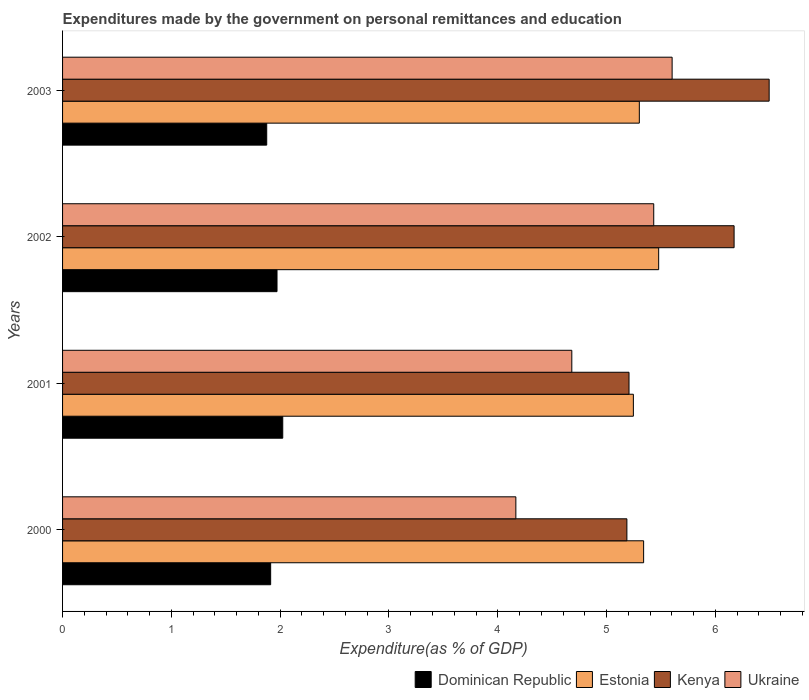How many groups of bars are there?
Provide a short and direct response. 4. Are the number of bars per tick equal to the number of legend labels?
Your answer should be very brief. Yes. What is the label of the 1st group of bars from the top?
Your response must be concise. 2003. What is the expenditures made by the government on personal remittances and education in Dominican Republic in 2001?
Offer a terse response. 2.02. Across all years, what is the maximum expenditures made by the government on personal remittances and education in Ukraine?
Keep it short and to the point. 5.6. Across all years, what is the minimum expenditures made by the government on personal remittances and education in Estonia?
Your answer should be very brief. 5.25. In which year was the expenditures made by the government on personal remittances and education in Dominican Republic maximum?
Give a very brief answer. 2001. What is the total expenditures made by the government on personal remittances and education in Kenya in the graph?
Provide a succinct answer. 23.06. What is the difference between the expenditures made by the government on personal remittances and education in Ukraine in 2001 and that in 2003?
Offer a very short reply. -0.92. What is the difference between the expenditures made by the government on personal remittances and education in Kenya in 2000 and the expenditures made by the government on personal remittances and education in Dominican Republic in 2002?
Your answer should be very brief. 3.22. What is the average expenditures made by the government on personal remittances and education in Kenya per year?
Offer a very short reply. 5.76. In the year 2002, what is the difference between the expenditures made by the government on personal remittances and education in Dominican Republic and expenditures made by the government on personal remittances and education in Estonia?
Your answer should be compact. -3.51. In how many years, is the expenditures made by the government on personal remittances and education in Dominican Republic greater than 0.4 %?
Your answer should be compact. 4. What is the ratio of the expenditures made by the government on personal remittances and education in Dominican Republic in 2000 to that in 2001?
Ensure brevity in your answer.  0.95. Is the expenditures made by the government on personal remittances and education in Kenya in 2002 less than that in 2003?
Provide a succinct answer. Yes. Is the difference between the expenditures made by the government on personal remittances and education in Dominican Republic in 2001 and 2002 greater than the difference between the expenditures made by the government on personal remittances and education in Estonia in 2001 and 2002?
Your response must be concise. Yes. What is the difference between the highest and the second highest expenditures made by the government on personal remittances and education in Ukraine?
Your response must be concise. 0.17. What is the difference between the highest and the lowest expenditures made by the government on personal remittances and education in Estonia?
Make the answer very short. 0.23. In how many years, is the expenditures made by the government on personal remittances and education in Dominican Republic greater than the average expenditures made by the government on personal remittances and education in Dominican Republic taken over all years?
Ensure brevity in your answer.  2. Is it the case that in every year, the sum of the expenditures made by the government on personal remittances and education in Ukraine and expenditures made by the government on personal remittances and education in Kenya is greater than the sum of expenditures made by the government on personal remittances and education in Dominican Republic and expenditures made by the government on personal remittances and education in Estonia?
Offer a very short reply. No. What does the 3rd bar from the top in 2001 represents?
Offer a terse response. Estonia. What does the 1st bar from the bottom in 2001 represents?
Provide a short and direct response. Dominican Republic. Is it the case that in every year, the sum of the expenditures made by the government on personal remittances and education in Estonia and expenditures made by the government on personal remittances and education in Ukraine is greater than the expenditures made by the government on personal remittances and education in Kenya?
Ensure brevity in your answer.  Yes. Are all the bars in the graph horizontal?
Keep it short and to the point. Yes. What is the difference between two consecutive major ticks on the X-axis?
Make the answer very short. 1. Does the graph contain any zero values?
Keep it short and to the point. No. Where does the legend appear in the graph?
Provide a short and direct response. Bottom right. How many legend labels are there?
Offer a terse response. 4. How are the legend labels stacked?
Your response must be concise. Horizontal. What is the title of the graph?
Provide a succinct answer. Expenditures made by the government on personal remittances and education. Does "Central African Republic" appear as one of the legend labels in the graph?
Your answer should be compact. No. What is the label or title of the X-axis?
Provide a short and direct response. Expenditure(as % of GDP). What is the Expenditure(as % of GDP) in Dominican Republic in 2000?
Ensure brevity in your answer.  1.91. What is the Expenditure(as % of GDP) of Estonia in 2000?
Provide a succinct answer. 5.34. What is the Expenditure(as % of GDP) of Kenya in 2000?
Provide a short and direct response. 5.19. What is the Expenditure(as % of GDP) of Ukraine in 2000?
Give a very brief answer. 4.17. What is the Expenditure(as % of GDP) of Dominican Republic in 2001?
Make the answer very short. 2.02. What is the Expenditure(as % of GDP) of Estonia in 2001?
Ensure brevity in your answer.  5.25. What is the Expenditure(as % of GDP) of Kenya in 2001?
Your answer should be very brief. 5.21. What is the Expenditure(as % of GDP) of Ukraine in 2001?
Your answer should be very brief. 4.68. What is the Expenditure(as % of GDP) in Dominican Republic in 2002?
Provide a short and direct response. 1.97. What is the Expenditure(as % of GDP) in Estonia in 2002?
Your answer should be compact. 5.48. What is the Expenditure(as % of GDP) in Kenya in 2002?
Provide a short and direct response. 6.17. What is the Expenditure(as % of GDP) of Ukraine in 2002?
Your answer should be very brief. 5.43. What is the Expenditure(as % of GDP) in Dominican Republic in 2003?
Provide a short and direct response. 1.88. What is the Expenditure(as % of GDP) in Estonia in 2003?
Your answer should be very brief. 5.3. What is the Expenditure(as % of GDP) of Kenya in 2003?
Give a very brief answer. 6.49. What is the Expenditure(as % of GDP) of Ukraine in 2003?
Provide a short and direct response. 5.6. Across all years, what is the maximum Expenditure(as % of GDP) of Dominican Republic?
Ensure brevity in your answer.  2.02. Across all years, what is the maximum Expenditure(as % of GDP) in Estonia?
Provide a short and direct response. 5.48. Across all years, what is the maximum Expenditure(as % of GDP) of Kenya?
Offer a very short reply. 6.49. Across all years, what is the maximum Expenditure(as % of GDP) in Ukraine?
Ensure brevity in your answer.  5.6. Across all years, what is the minimum Expenditure(as % of GDP) in Dominican Republic?
Provide a short and direct response. 1.88. Across all years, what is the minimum Expenditure(as % of GDP) of Estonia?
Make the answer very short. 5.25. Across all years, what is the minimum Expenditure(as % of GDP) of Kenya?
Your response must be concise. 5.19. Across all years, what is the minimum Expenditure(as % of GDP) in Ukraine?
Your answer should be very brief. 4.17. What is the total Expenditure(as % of GDP) in Dominican Republic in the graph?
Your answer should be compact. 7.78. What is the total Expenditure(as % of GDP) of Estonia in the graph?
Provide a short and direct response. 21.37. What is the total Expenditure(as % of GDP) in Kenya in the graph?
Your response must be concise. 23.06. What is the total Expenditure(as % of GDP) of Ukraine in the graph?
Your answer should be compact. 19.88. What is the difference between the Expenditure(as % of GDP) of Dominican Republic in 2000 and that in 2001?
Offer a terse response. -0.11. What is the difference between the Expenditure(as % of GDP) in Estonia in 2000 and that in 2001?
Your response must be concise. 0.09. What is the difference between the Expenditure(as % of GDP) of Kenya in 2000 and that in 2001?
Provide a short and direct response. -0.02. What is the difference between the Expenditure(as % of GDP) of Ukraine in 2000 and that in 2001?
Offer a terse response. -0.51. What is the difference between the Expenditure(as % of GDP) in Dominican Republic in 2000 and that in 2002?
Provide a succinct answer. -0.06. What is the difference between the Expenditure(as % of GDP) in Estonia in 2000 and that in 2002?
Your response must be concise. -0.14. What is the difference between the Expenditure(as % of GDP) of Kenya in 2000 and that in 2002?
Provide a succinct answer. -0.99. What is the difference between the Expenditure(as % of GDP) in Ukraine in 2000 and that in 2002?
Make the answer very short. -1.27. What is the difference between the Expenditure(as % of GDP) of Dominican Republic in 2000 and that in 2003?
Offer a very short reply. 0.04. What is the difference between the Expenditure(as % of GDP) in Estonia in 2000 and that in 2003?
Keep it short and to the point. 0.04. What is the difference between the Expenditure(as % of GDP) of Kenya in 2000 and that in 2003?
Your response must be concise. -1.31. What is the difference between the Expenditure(as % of GDP) of Ukraine in 2000 and that in 2003?
Offer a terse response. -1.44. What is the difference between the Expenditure(as % of GDP) of Dominican Republic in 2001 and that in 2002?
Keep it short and to the point. 0.05. What is the difference between the Expenditure(as % of GDP) in Estonia in 2001 and that in 2002?
Provide a succinct answer. -0.23. What is the difference between the Expenditure(as % of GDP) of Kenya in 2001 and that in 2002?
Keep it short and to the point. -0.97. What is the difference between the Expenditure(as % of GDP) in Ukraine in 2001 and that in 2002?
Provide a succinct answer. -0.75. What is the difference between the Expenditure(as % of GDP) of Dominican Republic in 2001 and that in 2003?
Provide a succinct answer. 0.15. What is the difference between the Expenditure(as % of GDP) in Estonia in 2001 and that in 2003?
Keep it short and to the point. -0.05. What is the difference between the Expenditure(as % of GDP) in Kenya in 2001 and that in 2003?
Make the answer very short. -1.29. What is the difference between the Expenditure(as % of GDP) in Ukraine in 2001 and that in 2003?
Your answer should be very brief. -0.92. What is the difference between the Expenditure(as % of GDP) in Dominican Republic in 2002 and that in 2003?
Provide a succinct answer. 0.09. What is the difference between the Expenditure(as % of GDP) of Estonia in 2002 and that in 2003?
Make the answer very short. 0.18. What is the difference between the Expenditure(as % of GDP) of Kenya in 2002 and that in 2003?
Provide a succinct answer. -0.32. What is the difference between the Expenditure(as % of GDP) of Ukraine in 2002 and that in 2003?
Keep it short and to the point. -0.17. What is the difference between the Expenditure(as % of GDP) of Dominican Republic in 2000 and the Expenditure(as % of GDP) of Estonia in 2001?
Make the answer very short. -3.33. What is the difference between the Expenditure(as % of GDP) in Dominican Republic in 2000 and the Expenditure(as % of GDP) in Kenya in 2001?
Give a very brief answer. -3.29. What is the difference between the Expenditure(as % of GDP) in Dominican Republic in 2000 and the Expenditure(as % of GDP) in Ukraine in 2001?
Provide a succinct answer. -2.77. What is the difference between the Expenditure(as % of GDP) in Estonia in 2000 and the Expenditure(as % of GDP) in Kenya in 2001?
Offer a very short reply. 0.13. What is the difference between the Expenditure(as % of GDP) of Estonia in 2000 and the Expenditure(as % of GDP) of Ukraine in 2001?
Ensure brevity in your answer.  0.66. What is the difference between the Expenditure(as % of GDP) of Kenya in 2000 and the Expenditure(as % of GDP) of Ukraine in 2001?
Provide a succinct answer. 0.51. What is the difference between the Expenditure(as % of GDP) of Dominican Republic in 2000 and the Expenditure(as % of GDP) of Estonia in 2002?
Give a very brief answer. -3.57. What is the difference between the Expenditure(as % of GDP) of Dominican Republic in 2000 and the Expenditure(as % of GDP) of Kenya in 2002?
Make the answer very short. -4.26. What is the difference between the Expenditure(as % of GDP) in Dominican Republic in 2000 and the Expenditure(as % of GDP) in Ukraine in 2002?
Provide a succinct answer. -3.52. What is the difference between the Expenditure(as % of GDP) in Estonia in 2000 and the Expenditure(as % of GDP) in Kenya in 2002?
Keep it short and to the point. -0.83. What is the difference between the Expenditure(as % of GDP) of Estonia in 2000 and the Expenditure(as % of GDP) of Ukraine in 2002?
Ensure brevity in your answer.  -0.09. What is the difference between the Expenditure(as % of GDP) of Kenya in 2000 and the Expenditure(as % of GDP) of Ukraine in 2002?
Ensure brevity in your answer.  -0.25. What is the difference between the Expenditure(as % of GDP) of Dominican Republic in 2000 and the Expenditure(as % of GDP) of Estonia in 2003?
Keep it short and to the point. -3.39. What is the difference between the Expenditure(as % of GDP) of Dominican Republic in 2000 and the Expenditure(as % of GDP) of Kenya in 2003?
Give a very brief answer. -4.58. What is the difference between the Expenditure(as % of GDP) in Dominican Republic in 2000 and the Expenditure(as % of GDP) in Ukraine in 2003?
Keep it short and to the point. -3.69. What is the difference between the Expenditure(as % of GDP) of Estonia in 2000 and the Expenditure(as % of GDP) of Kenya in 2003?
Keep it short and to the point. -1.15. What is the difference between the Expenditure(as % of GDP) of Estonia in 2000 and the Expenditure(as % of GDP) of Ukraine in 2003?
Make the answer very short. -0.26. What is the difference between the Expenditure(as % of GDP) in Kenya in 2000 and the Expenditure(as % of GDP) in Ukraine in 2003?
Offer a terse response. -0.42. What is the difference between the Expenditure(as % of GDP) of Dominican Republic in 2001 and the Expenditure(as % of GDP) of Estonia in 2002?
Give a very brief answer. -3.46. What is the difference between the Expenditure(as % of GDP) in Dominican Republic in 2001 and the Expenditure(as % of GDP) in Kenya in 2002?
Give a very brief answer. -4.15. What is the difference between the Expenditure(as % of GDP) of Dominican Republic in 2001 and the Expenditure(as % of GDP) of Ukraine in 2002?
Keep it short and to the point. -3.41. What is the difference between the Expenditure(as % of GDP) of Estonia in 2001 and the Expenditure(as % of GDP) of Kenya in 2002?
Offer a very short reply. -0.93. What is the difference between the Expenditure(as % of GDP) in Estonia in 2001 and the Expenditure(as % of GDP) in Ukraine in 2002?
Make the answer very short. -0.19. What is the difference between the Expenditure(as % of GDP) of Kenya in 2001 and the Expenditure(as % of GDP) of Ukraine in 2002?
Your answer should be very brief. -0.23. What is the difference between the Expenditure(as % of GDP) of Dominican Republic in 2001 and the Expenditure(as % of GDP) of Estonia in 2003?
Your answer should be very brief. -3.28. What is the difference between the Expenditure(as % of GDP) in Dominican Republic in 2001 and the Expenditure(as % of GDP) in Kenya in 2003?
Provide a succinct answer. -4.47. What is the difference between the Expenditure(as % of GDP) in Dominican Republic in 2001 and the Expenditure(as % of GDP) in Ukraine in 2003?
Your answer should be very brief. -3.58. What is the difference between the Expenditure(as % of GDP) of Estonia in 2001 and the Expenditure(as % of GDP) of Kenya in 2003?
Give a very brief answer. -1.25. What is the difference between the Expenditure(as % of GDP) in Estonia in 2001 and the Expenditure(as % of GDP) in Ukraine in 2003?
Offer a terse response. -0.36. What is the difference between the Expenditure(as % of GDP) in Kenya in 2001 and the Expenditure(as % of GDP) in Ukraine in 2003?
Give a very brief answer. -0.4. What is the difference between the Expenditure(as % of GDP) in Dominican Republic in 2002 and the Expenditure(as % of GDP) in Estonia in 2003?
Offer a terse response. -3.33. What is the difference between the Expenditure(as % of GDP) in Dominican Republic in 2002 and the Expenditure(as % of GDP) in Kenya in 2003?
Offer a terse response. -4.52. What is the difference between the Expenditure(as % of GDP) of Dominican Republic in 2002 and the Expenditure(as % of GDP) of Ukraine in 2003?
Provide a succinct answer. -3.63. What is the difference between the Expenditure(as % of GDP) in Estonia in 2002 and the Expenditure(as % of GDP) in Kenya in 2003?
Your answer should be compact. -1.02. What is the difference between the Expenditure(as % of GDP) of Estonia in 2002 and the Expenditure(as % of GDP) of Ukraine in 2003?
Offer a terse response. -0.12. What is the difference between the Expenditure(as % of GDP) of Kenya in 2002 and the Expenditure(as % of GDP) of Ukraine in 2003?
Your answer should be compact. 0.57. What is the average Expenditure(as % of GDP) in Dominican Republic per year?
Provide a succinct answer. 1.95. What is the average Expenditure(as % of GDP) of Estonia per year?
Provide a short and direct response. 5.34. What is the average Expenditure(as % of GDP) in Kenya per year?
Keep it short and to the point. 5.76. What is the average Expenditure(as % of GDP) of Ukraine per year?
Your answer should be compact. 4.97. In the year 2000, what is the difference between the Expenditure(as % of GDP) in Dominican Republic and Expenditure(as % of GDP) in Estonia?
Your answer should be compact. -3.43. In the year 2000, what is the difference between the Expenditure(as % of GDP) in Dominican Republic and Expenditure(as % of GDP) in Kenya?
Your answer should be compact. -3.27. In the year 2000, what is the difference between the Expenditure(as % of GDP) of Dominican Republic and Expenditure(as % of GDP) of Ukraine?
Provide a succinct answer. -2.25. In the year 2000, what is the difference between the Expenditure(as % of GDP) of Estonia and Expenditure(as % of GDP) of Kenya?
Ensure brevity in your answer.  0.15. In the year 2000, what is the difference between the Expenditure(as % of GDP) of Estonia and Expenditure(as % of GDP) of Ukraine?
Provide a short and direct response. 1.17. In the year 2000, what is the difference between the Expenditure(as % of GDP) of Kenya and Expenditure(as % of GDP) of Ukraine?
Offer a very short reply. 1.02. In the year 2001, what is the difference between the Expenditure(as % of GDP) of Dominican Republic and Expenditure(as % of GDP) of Estonia?
Keep it short and to the point. -3.22. In the year 2001, what is the difference between the Expenditure(as % of GDP) of Dominican Republic and Expenditure(as % of GDP) of Kenya?
Ensure brevity in your answer.  -3.18. In the year 2001, what is the difference between the Expenditure(as % of GDP) in Dominican Republic and Expenditure(as % of GDP) in Ukraine?
Provide a succinct answer. -2.66. In the year 2001, what is the difference between the Expenditure(as % of GDP) of Estonia and Expenditure(as % of GDP) of Ukraine?
Offer a very short reply. 0.57. In the year 2001, what is the difference between the Expenditure(as % of GDP) of Kenya and Expenditure(as % of GDP) of Ukraine?
Give a very brief answer. 0.53. In the year 2002, what is the difference between the Expenditure(as % of GDP) in Dominican Republic and Expenditure(as % of GDP) in Estonia?
Make the answer very short. -3.51. In the year 2002, what is the difference between the Expenditure(as % of GDP) of Dominican Republic and Expenditure(as % of GDP) of Kenya?
Make the answer very short. -4.2. In the year 2002, what is the difference between the Expenditure(as % of GDP) in Dominican Republic and Expenditure(as % of GDP) in Ukraine?
Give a very brief answer. -3.46. In the year 2002, what is the difference between the Expenditure(as % of GDP) of Estonia and Expenditure(as % of GDP) of Kenya?
Ensure brevity in your answer.  -0.69. In the year 2002, what is the difference between the Expenditure(as % of GDP) of Estonia and Expenditure(as % of GDP) of Ukraine?
Provide a succinct answer. 0.05. In the year 2002, what is the difference between the Expenditure(as % of GDP) in Kenya and Expenditure(as % of GDP) in Ukraine?
Provide a short and direct response. 0.74. In the year 2003, what is the difference between the Expenditure(as % of GDP) of Dominican Republic and Expenditure(as % of GDP) of Estonia?
Ensure brevity in your answer.  -3.42. In the year 2003, what is the difference between the Expenditure(as % of GDP) in Dominican Republic and Expenditure(as % of GDP) in Kenya?
Your response must be concise. -4.62. In the year 2003, what is the difference between the Expenditure(as % of GDP) in Dominican Republic and Expenditure(as % of GDP) in Ukraine?
Provide a short and direct response. -3.73. In the year 2003, what is the difference between the Expenditure(as % of GDP) in Estonia and Expenditure(as % of GDP) in Kenya?
Your answer should be very brief. -1.19. In the year 2003, what is the difference between the Expenditure(as % of GDP) of Estonia and Expenditure(as % of GDP) of Ukraine?
Give a very brief answer. -0.3. In the year 2003, what is the difference between the Expenditure(as % of GDP) of Kenya and Expenditure(as % of GDP) of Ukraine?
Keep it short and to the point. 0.89. What is the ratio of the Expenditure(as % of GDP) of Dominican Republic in 2000 to that in 2001?
Your response must be concise. 0.95. What is the ratio of the Expenditure(as % of GDP) of Estonia in 2000 to that in 2001?
Your answer should be very brief. 1.02. What is the ratio of the Expenditure(as % of GDP) in Kenya in 2000 to that in 2001?
Offer a very short reply. 1. What is the ratio of the Expenditure(as % of GDP) of Ukraine in 2000 to that in 2001?
Ensure brevity in your answer.  0.89. What is the ratio of the Expenditure(as % of GDP) of Dominican Republic in 2000 to that in 2002?
Your response must be concise. 0.97. What is the ratio of the Expenditure(as % of GDP) of Estonia in 2000 to that in 2002?
Your answer should be very brief. 0.97. What is the ratio of the Expenditure(as % of GDP) in Kenya in 2000 to that in 2002?
Your response must be concise. 0.84. What is the ratio of the Expenditure(as % of GDP) of Ukraine in 2000 to that in 2002?
Your answer should be very brief. 0.77. What is the ratio of the Expenditure(as % of GDP) in Dominican Republic in 2000 to that in 2003?
Offer a very short reply. 1.02. What is the ratio of the Expenditure(as % of GDP) in Estonia in 2000 to that in 2003?
Ensure brevity in your answer.  1.01. What is the ratio of the Expenditure(as % of GDP) in Kenya in 2000 to that in 2003?
Your response must be concise. 0.8. What is the ratio of the Expenditure(as % of GDP) in Ukraine in 2000 to that in 2003?
Your answer should be very brief. 0.74. What is the ratio of the Expenditure(as % of GDP) of Dominican Republic in 2001 to that in 2002?
Keep it short and to the point. 1.03. What is the ratio of the Expenditure(as % of GDP) in Estonia in 2001 to that in 2002?
Provide a succinct answer. 0.96. What is the ratio of the Expenditure(as % of GDP) of Kenya in 2001 to that in 2002?
Offer a very short reply. 0.84. What is the ratio of the Expenditure(as % of GDP) of Ukraine in 2001 to that in 2002?
Provide a succinct answer. 0.86. What is the ratio of the Expenditure(as % of GDP) in Dominican Republic in 2001 to that in 2003?
Offer a terse response. 1.08. What is the ratio of the Expenditure(as % of GDP) in Kenya in 2001 to that in 2003?
Ensure brevity in your answer.  0.8. What is the ratio of the Expenditure(as % of GDP) in Ukraine in 2001 to that in 2003?
Provide a short and direct response. 0.84. What is the ratio of the Expenditure(as % of GDP) in Dominican Republic in 2002 to that in 2003?
Provide a short and direct response. 1.05. What is the ratio of the Expenditure(as % of GDP) of Estonia in 2002 to that in 2003?
Your response must be concise. 1.03. What is the ratio of the Expenditure(as % of GDP) of Kenya in 2002 to that in 2003?
Ensure brevity in your answer.  0.95. What is the ratio of the Expenditure(as % of GDP) in Ukraine in 2002 to that in 2003?
Your response must be concise. 0.97. What is the difference between the highest and the second highest Expenditure(as % of GDP) of Dominican Republic?
Give a very brief answer. 0.05. What is the difference between the highest and the second highest Expenditure(as % of GDP) in Estonia?
Keep it short and to the point. 0.14. What is the difference between the highest and the second highest Expenditure(as % of GDP) of Kenya?
Your answer should be very brief. 0.32. What is the difference between the highest and the second highest Expenditure(as % of GDP) of Ukraine?
Your answer should be compact. 0.17. What is the difference between the highest and the lowest Expenditure(as % of GDP) of Dominican Republic?
Your response must be concise. 0.15. What is the difference between the highest and the lowest Expenditure(as % of GDP) in Estonia?
Give a very brief answer. 0.23. What is the difference between the highest and the lowest Expenditure(as % of GDP) of Kenya?
Provide a succinct answer. 1.31. What is the difference between the highest and the lowest Expenditure(as % of GDP) in Ukraine?
Make the answer very short. 1.44. 